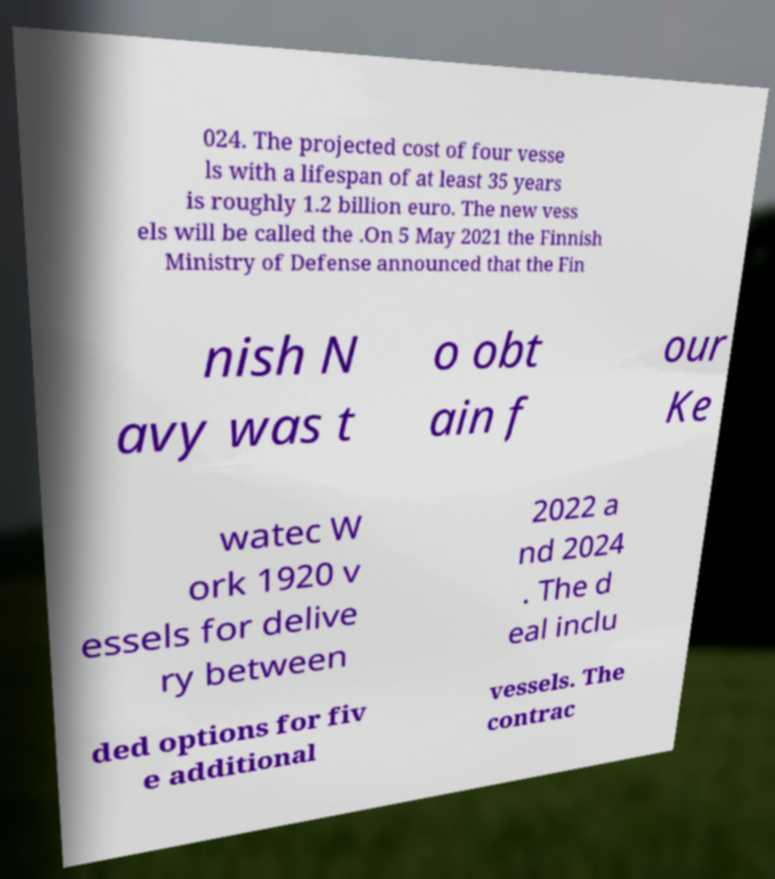Please identify and transcribe the text found in this image. 024. The projected cost of four vesse ls with a lifespan of at least 35 years is roughly 1.2 billion euro. The new vess els will be called the .On 5 May 2021 the Finnish Ministry of Defense announced that the Fin nish N avy was t o obt ain f our Ke watec W ork 1920 v essels for delive ry between 2022 a nd 2024 . The d eal inclu ded options for fiv e additional vessels. The contrac 